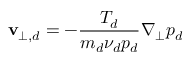Convert formula to latex. <formula><loc_0><loc_0><loc_500><loc_500>v _ { \perp , d } = - \frac { T _ { d } } { m _ { d } \nu _ { d } p _ { d } } \nabla _ { \perp } p _ { d }</formula> 